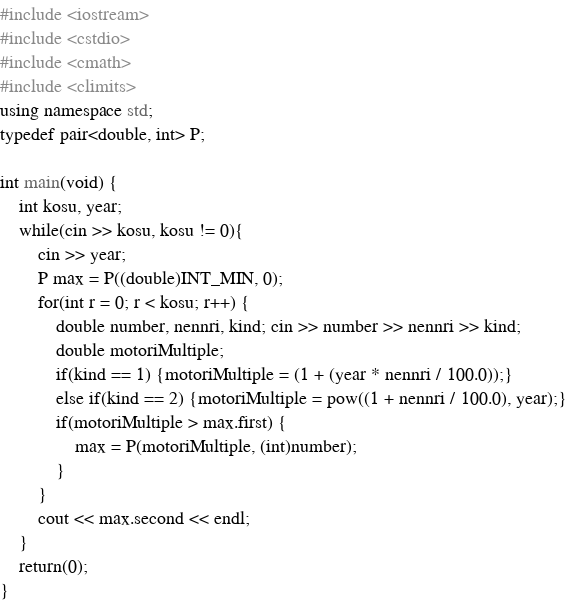<code> <loc_0><loc_0><loc_500><loc_500><_C++_>#include <iostream>
#include <cstdio>
#include <cmath>
#include <climits>
using namespace std;
typedef pair<double, int> P;

int main(void) {
    int kosu, year;
    while(cin >> kosu, kosu != 0){
        cin >> year;
        P max = P((double)INT_MIN, 0);
        for(int r = 0; r < kosu; r++) {
            double number, nennri, kind; cin >> number >> nennri >> kind;
            double motoriMultiple;
            if(kind == 1) {motoriMultiple = (1 + (year * nennri / 100.0));}
            else if(kind == 2) {motoriMultiple = pow((1 + nennri / 100.0), year);}
            if(motoriMultiple > max.first) {
                max = P(motoriMultiple, (int)number);
            }
        }
        cout << max.second << endl;
    }
    return(0);
}</code> 